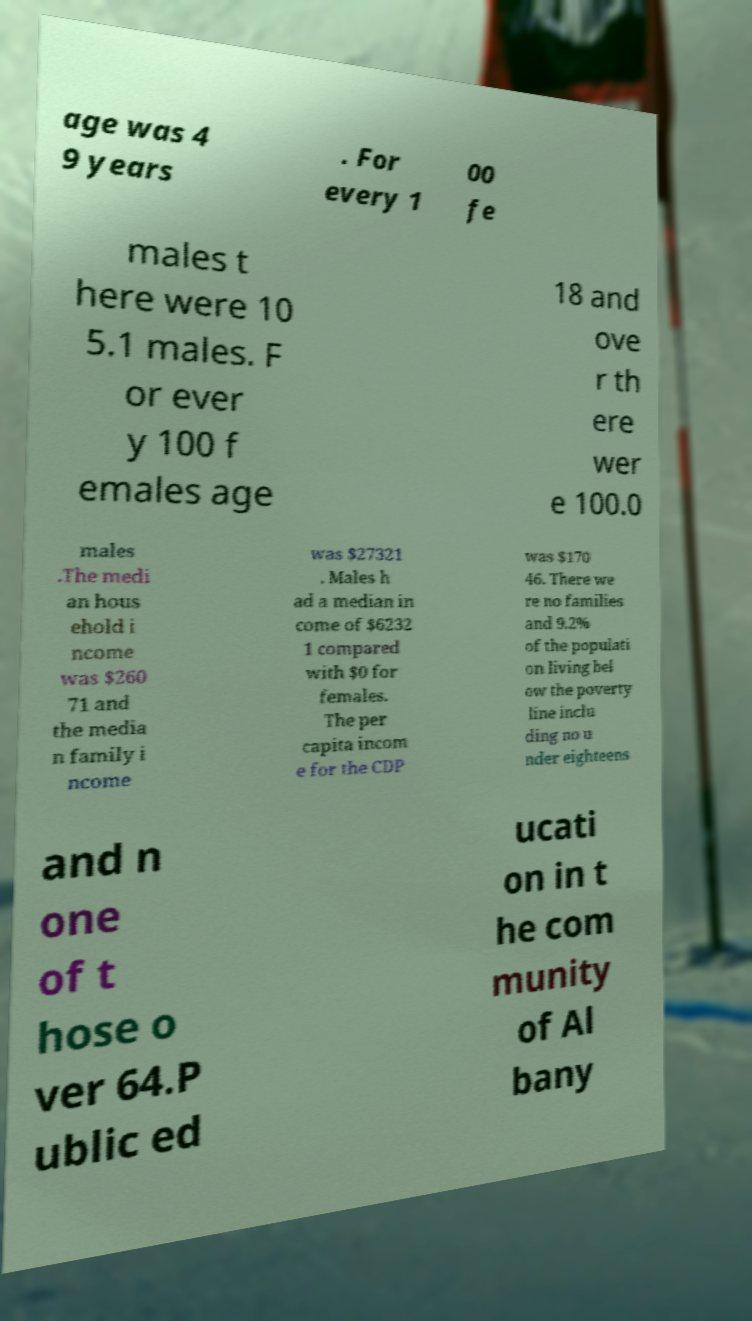Could you extract and type out the text from this image? age was 4 9 years . For every 1 00 fe males t here were 10 5.1 males. F or ever y 100 f emales age 18 and ove r th ere wer e 100.0 males .The medi an hous ehold i ncome was $260 71 and the media n family i ncome was $27321 . Males h ad a median in come of $6232 1 compared with $0 for females. The per capita incom e for the CDP was $170 46. There we re no families and 9.2% of the populati on living bel ow the poverty line inclu ding no u nder eighteens and n one of t hose o ver 64.P ublic ed ucati on in t he com munity of Al bany 